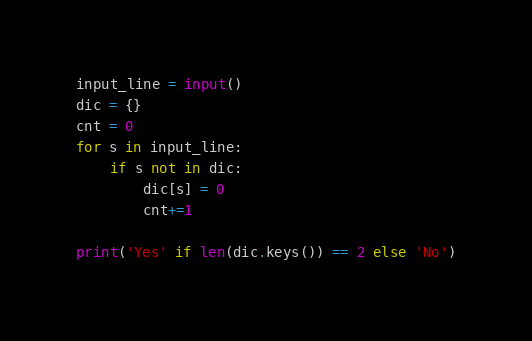Convert code to text. <code><loc_0><loc_0><loc_500><loc_500><_Python_>input_line = input()
dic = {}
cnt = 0
for s in input_line:
    if s not in dic:
        dic[s] = 0
        cnt+=1

print('Yes' if len(dic.keys()) == 2 else 'No')</code> 